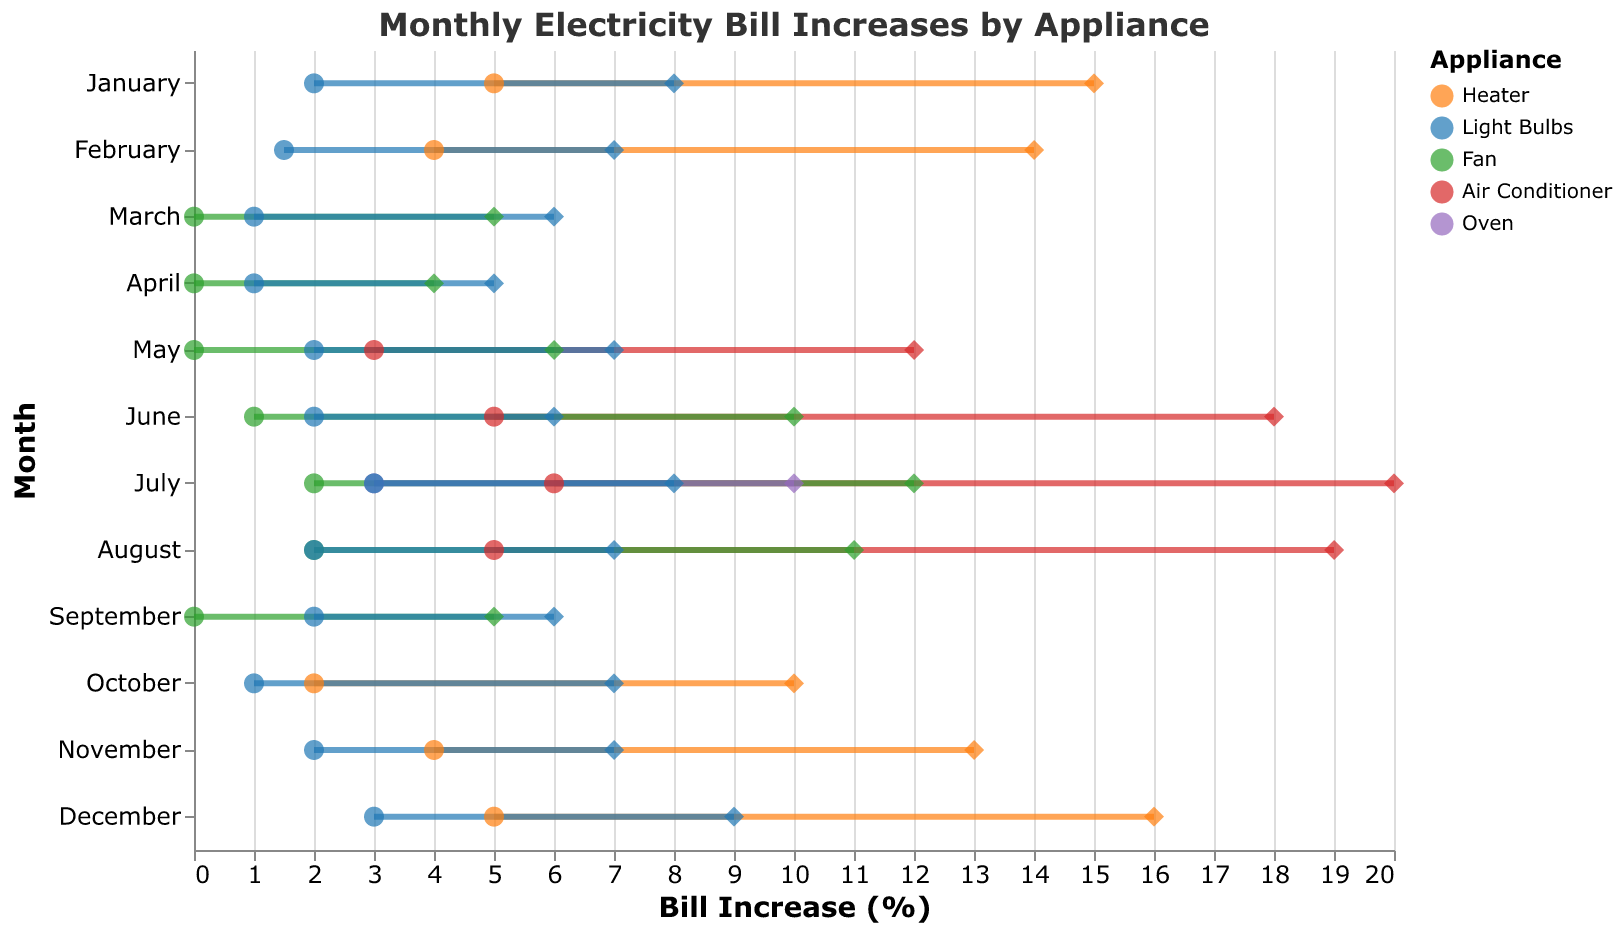What is the range of the bill increase for the heater in January? The heater in January shows a minimum bill increase of 5% and a maximum of 15%. The range is obtained by subtracting the minimum value from the maximum value.
Answer: 10% Which appliance has the highest maximum bill increase in the month of July? In July, the appliances listed are Air Conditioner, Fan, Oven, and Light Bulbs. The maximum bill increases are 20%, 12%, 10%, and 8%, respectively. Therefore, the appliance with the highest maximum bill increase is the Air Conditioner.
Answer: Air Conditioner Compare the average minimum bill increase of the Heater in January and November. Which month has a lower average minimum increase? The minimum bill increase for the Heater in January is 5%, and for November is 4%. Since 4% is less than 5%, November has a lower average minimum increase.
Answer: November During which month does the Air Conditioner show the highest maximum bill increase? The Air Conditioner is shown in the months of May, June, July, and August. The maximum bill increases are 12%, 18%, 20%, and 19%, respectively. The highest maximum increase for the Air Conditioner is in July.
Answer: July Which appliance consistently shows up across all months with significant bill increases? Light Bulbs are mentioned in every month with minimum and maximum bill increases provided, indicating they consistently contribute to the bill throughout the year.
Answer: Light Bulbs What is the difference between the maximum bill increase of the Air Conditioner in June and August? The maximum bill increase for the Air Conditioner in June is 18%, and in August, it is 19%. Subtracting these values, the difference is 19% - 18% = 1%.
Answer: 1% What appliance shows zero minimum bill increase in March and April? Looking at the minimum bill increases, the Fan shows a zero minimum bill increase in both March and April.
Answer: Fan What is the total range of bill increase percentage for Light Bulbs in December? For Light Bulbs in December, the minimum bill increase is 3%, and the maximum is 9%. The range is calculated by subtracting the minimum from the maximum, which gives 9% - 3% = 6%.
Answer: 6% List the months where the Fan’s maximum bill increase is greater than its minimum bill increase by at least 10%. The Fan's maximum and minimum bill increases per month are: March (5% and 0%), April (4% and 0%), May (6% and 0%), June (10% and 1%), July (12% and 2%), August (11% and 2%), September (5% and 0%). The differences are: 5%, 4%, 6%, 9%, 10%, 9%, and 5%. Therefore, July is the month where the difference is at least 10%.
Answer: July 